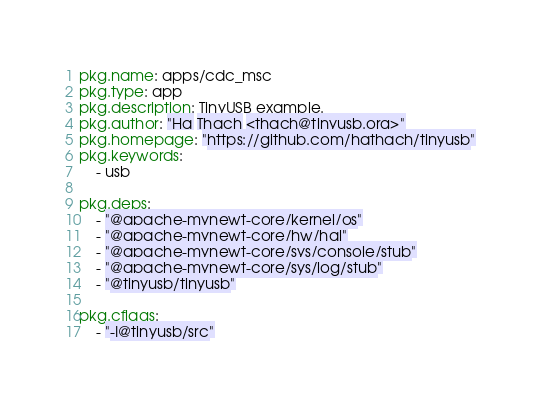<code> <loc_0><loc_0><loc_500><loc_500><_YAML_>pkg.name: apps/cdc_msc
pkg.type: app
pkg.description: TinyUSB example.
pkg.author: "Ha Thach <thach@tinyusb.org>"
pkg.homepage: "https://github.com/hathach/tinyusb"
pkg.keywords:
    - usb

pkg.deps:
    - "@apache-mynewt-core/kernel/os"
    - "@apache-mynewt-core/hw/hal"
    - "@apache-mynewt-core/sys/console/stub"
    - "@apache-mynewt-core/sys/log/stub"
    - "@tinyusb/tinyusb"

pkg.cflags: 
    - "-I@tinyusb/src"
</code> 